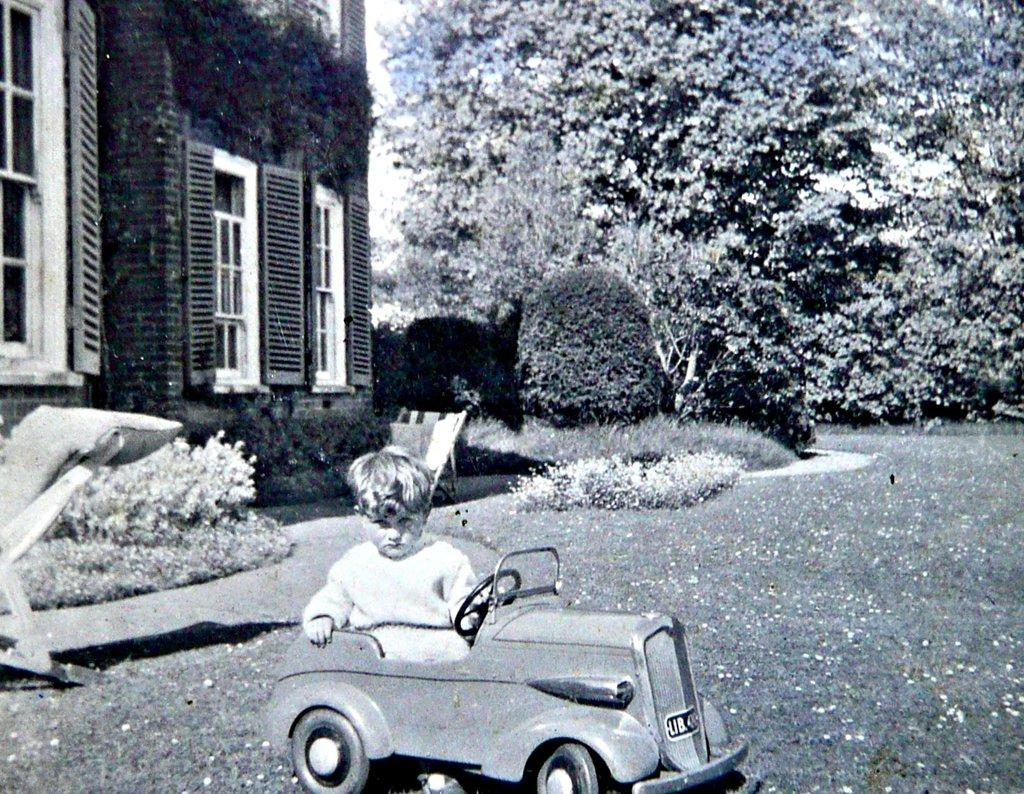What is the child doing in the image? The child is in a toy car in the image. What can be seen in the background of the image? There is a tree, a small plant, a window, and a building in the background of the image. What type of yak can be seen grazing near the building in the image? There is no yak present in the image; it only features a child in a toy car and various background elements. 